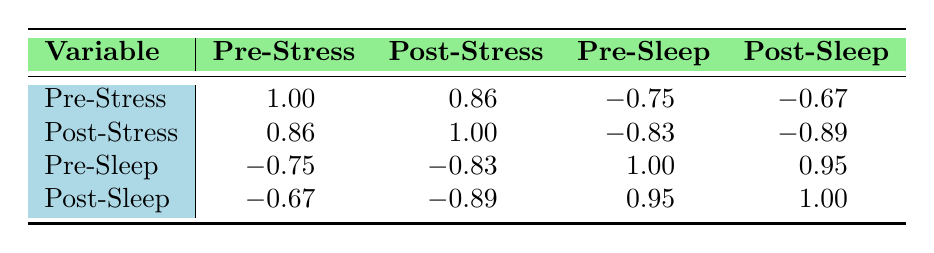What is the correlation between pre-hypnosis stress levels and post-hypnosis stress levels? According to the table, the correlation value is 0.86, indicating a strong positive relationship between pre-hypnosis stress levels and post-hypnosis stress levels.
Answer: 0.86 What is the correlation between pre-hypnosis sleep quality and post-hypnosis sleep quality? The table shows a correlation of 1.00 between pre-hypnosis sleep quality and post-hypnosis sleep quality, which indicates a perfect positive correlation, meaning they move together perfectly.
Answer: 1.00 Is the correlation between pre-hypnosis stress levels and post-hypnosis sleep quality positive or negative? The correlation between pre-hypnosis stress levels and post-hypnosis sleep quality is -0.67, which indicates a negative correlation, meaning as stress levels increase, sleep quality tends to decrease.
Answer: Negative What is the average correlation value between pre-sleep and post-sleep measures? To find the average, we add up the correlation values for pre-sleep to post-sleep, which are -0.67 and 0.95. The total is 0.28. Since there are two values, the average is 0.28/2 = 0.14.
Answer: 0.14 Is there a strong negative correlation between pre-hypnosis stress levels and pre-hypnosis sleep quality? The correlation value between pre-hypnosis stress levels and pre-hypnosis sleep quality is -0.75. This suggests a strong negative correlation, which indicates that higher stress levels are associated with lower sleep quality.
Answer: Yes What is the difference in correlation between post-hypnosis stress level and pre-hypnosis sleep quality? The correlation value for post-hypnosis stress level is -0.89 and for pre-hypnosis sleep quality is -0.75. The difference is -0.89 - (-0.75) = -0.14, indicating that the post-hypnosis stress level is more negatively correlated with sleep quality than the pre-hypnosis stress level.
Answer: -0.14 What do the correlations indicate about the relationship between post-hypnosis stress levels and sleep quality? The table shows a strong negative correlation of -0.89 between post-hypnosis stress levels and post-hypnosis sleep quality. This indicates that as stress levels decrease post-hypnosis, sleep quality improves significantly.
Answer: Strong negative correlation What is the highest correlation observed in the table? The highest correlation observed in the table is 1.00 between pre-hypnosis sleep quality and post-hypnosis sleep quality, indicating they are perfectly positively correlated.
Answer: 1.00 